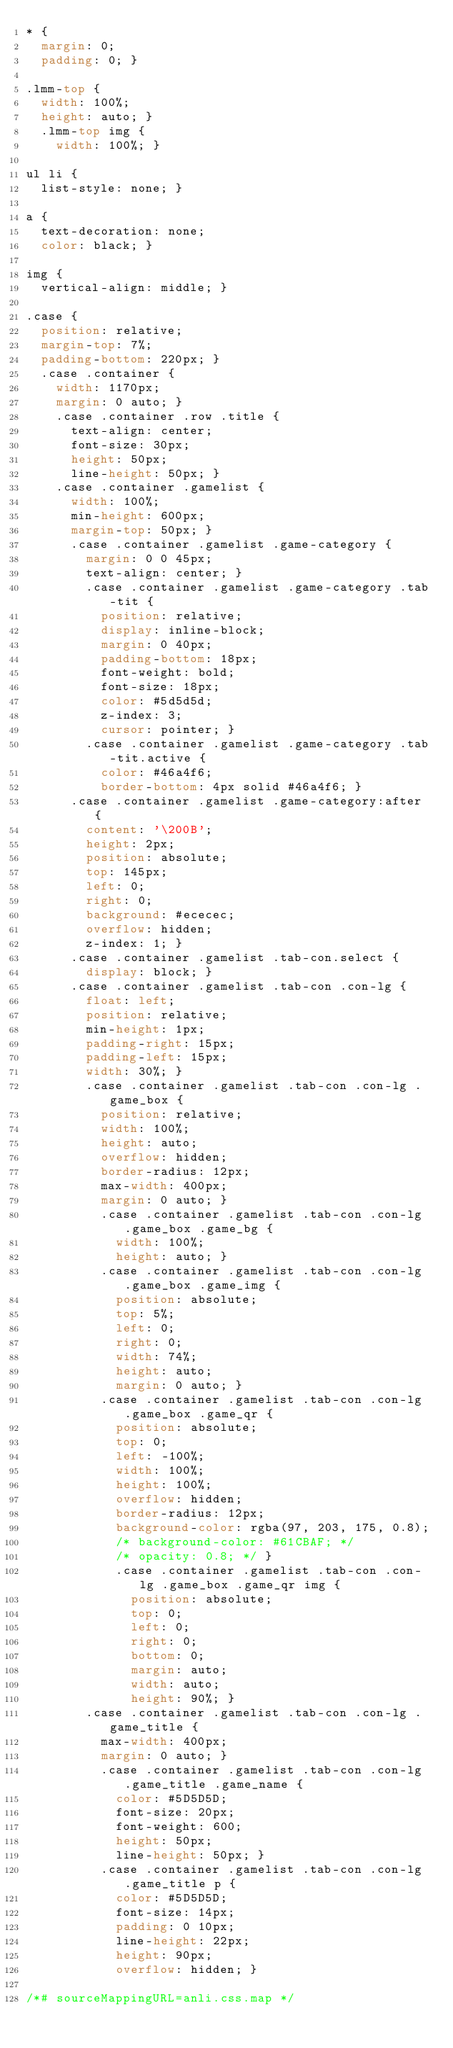<code> <loc_0><loc_0><loc_500><loc_500><_CSS_>* {
  margin: 0;
  padding: 0; }

.lmm-top {
  width: 100%;
  height: auto; }
  .lmm-top img {
    width: 100%; }

ul li {
  list-style: none; }

a {
  text-decoration: none;
  color: black; }

img {
  vertical-align: middle; }

.case {
  position: relative;
  margin-top: 7%;
  padding-bottom: 220px; }
  .case .container {
    width: 1170px;
    margin: 0 auto; }
    .case .container .row .title {
      text-align: center;
      font-size: 30px;
      height: 50px;
      line-height: 50px; }
    .case .container .gamelist {
      width: 100%;
      min-height: 600px;
      margin-top: 50px; }
      .case .container .gamelist .game-category {
        margin: 0 0 45px;
        text-align: center; }
        .case .container .gamelist .game-category .tab-tit {
          position: relative;
          display: inline-block;
          margin: 0 40px;
          padding-bottom: 18px;
          font-weight: bold;
          font-size: 18px;
          color: #5d5d5d;
          z-index: 3;
          cursor: pointer; }
        .case .container .gamelist .game-category .tab-tit.active {
          color: #46a4f6;
          border-bottom: 4px solid #46a4f6; }
      .case .container .gamelist .game-category:after {
        content: '\200B';
        height: 2px;
        position: absolute;
        top: 145px;
        left: 0;
        right: 0;
        background: #ececec;
        overflow: hidden;
        z-index: 1; }
      .case .container .gamelist .tab-con.select {
        display: block; }
      .case .container .gamelist .tab-con .con-lg {
        float: left;
        position: relative;
        min-height: 1px;
        padding-right: 15px;
        padding-left: 15px;
        width: 30%; }
        .case .container .gamelist .tab-con .con-lg .game_box {
          position: relative;
          width: 100%;
          height: auto;
          overflow: hidden;
          border-radius: 12px;
          max-width: 400px;
          margin: 0 auto; }
          .case .container .gamelist .tab-con .con-lg .game_box .game_bg {
            width: 100%;
            height: auto; }
          .case .container .gamelist .tab-con .con-lg .game_box .game_img {
            position: absolute;
            top: 5%;
            left: 0;
            right: 0;
            width: 74%;
            height: auto;
            margin: 0 auto; }
          .case .container .gamelist .tab-con .con-lg .game_box .game_qr {
            position: absolute;
            top: 0;
            left: -100%;
            width: 100%;
            height: 100%;
            overflow: hidden;
            border-radius: 12px;
            background-color: rgba(97, 203, 175, 0.8);
            /* background-color: #61CBAF; */
            /* opacity: 0.8; */ }
            .case .container .gamelist .tab-con .con-lg .game_box .game_qr img {
              position: absolute;
              top: 0;
              left: 0;
              right: 0;
              bottom: 0;
              margin: auto;
              width: auto;
              height: 90%; }
        .case .container .gamelist .tab-con .con-lg .game_title {
          max-width: 400px;
          margin: 0 auto; }
          .case .container .gamelist .tab-con .con-lg .game_title .game_name {
            color: #5D5D5D;
            font-size: 20px;
            font-weight: 600;
            height: 50px;
            line-height: 50px; }
          .case .container .gamelist .tab-con .con-lg .game_title p {
            color: #5D5D5D;
            font-size: 14px;
            padding: 0 10px;
            line-height: 22px;
            height: 90px;
            overflow: hidden; }

/*# sourceMappingURL=anli.css.map */
</code> 